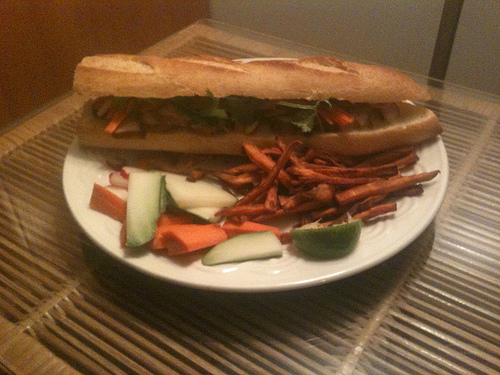<image>
Can you confirm if the carrot is in front of the sandwich? Yes. The carrot is positioned in front of the sandwich, appearing closer to the camera viewpoint. 